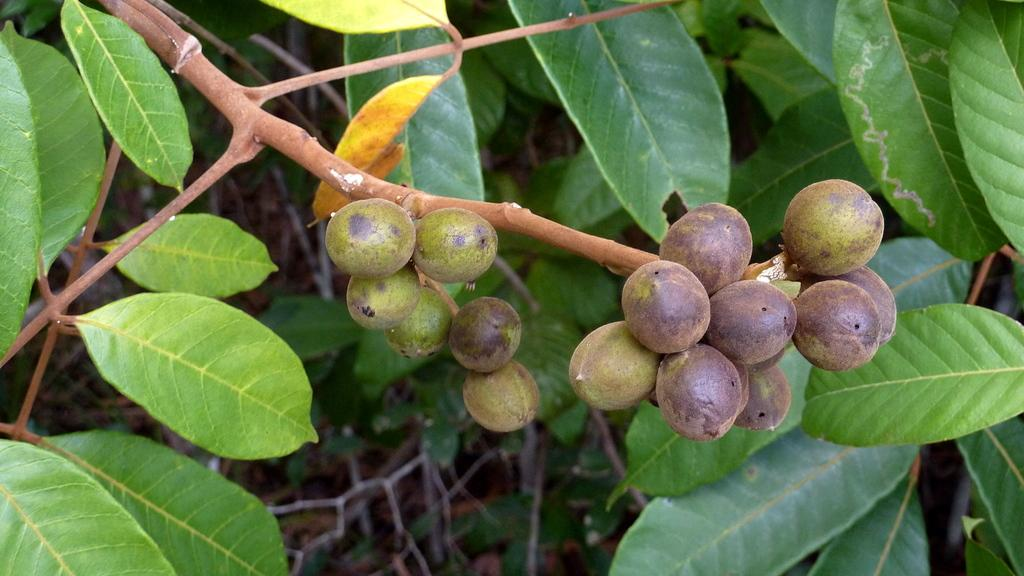What type of objects are in the center of the image? There are objects in the center of the image that resemble fruits. How are the fruits positioned in the image? The fruits are hanging on a stem. What type of vegetation is visible in the image? There are green leaves visible in the image. Can you describe any other objects present in the image? There are other unspecified objects present in the image. How many grapes are connected to the bulb in the image? There is no bulb or grapes present in the image. What type of body is visible in the image? There is no body visible in the image; it features fruits hanging on a stem and green leaves. 